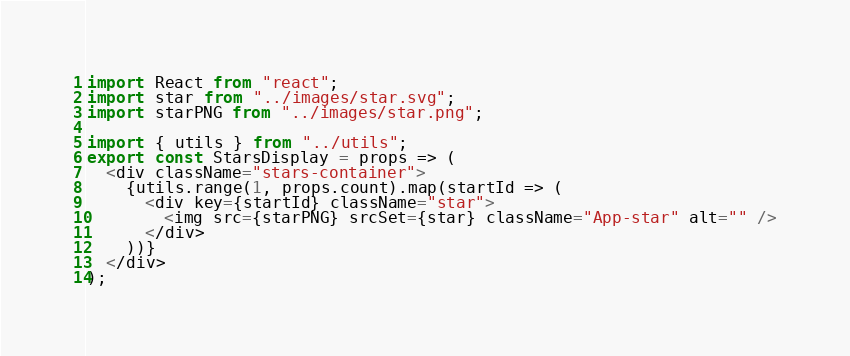Convert code to text. <code><loc_0><loc_0><loc_500><loc_500><_JavaScript_>import React from "react";
import star from "../images/star.svg";
import starPNG from "../images/star.png";

import { utils } from "../utils";
export const StarsDisplay = props => (
  <div className="stars-container">
    {utils.range(1, props.count).map(startId => (
      <div key={startId} className="star">
        <img src={starPNG} srcSet={star} className="App-star" alt="" />
      </div>
    ))}
  </div>
);
</code> 